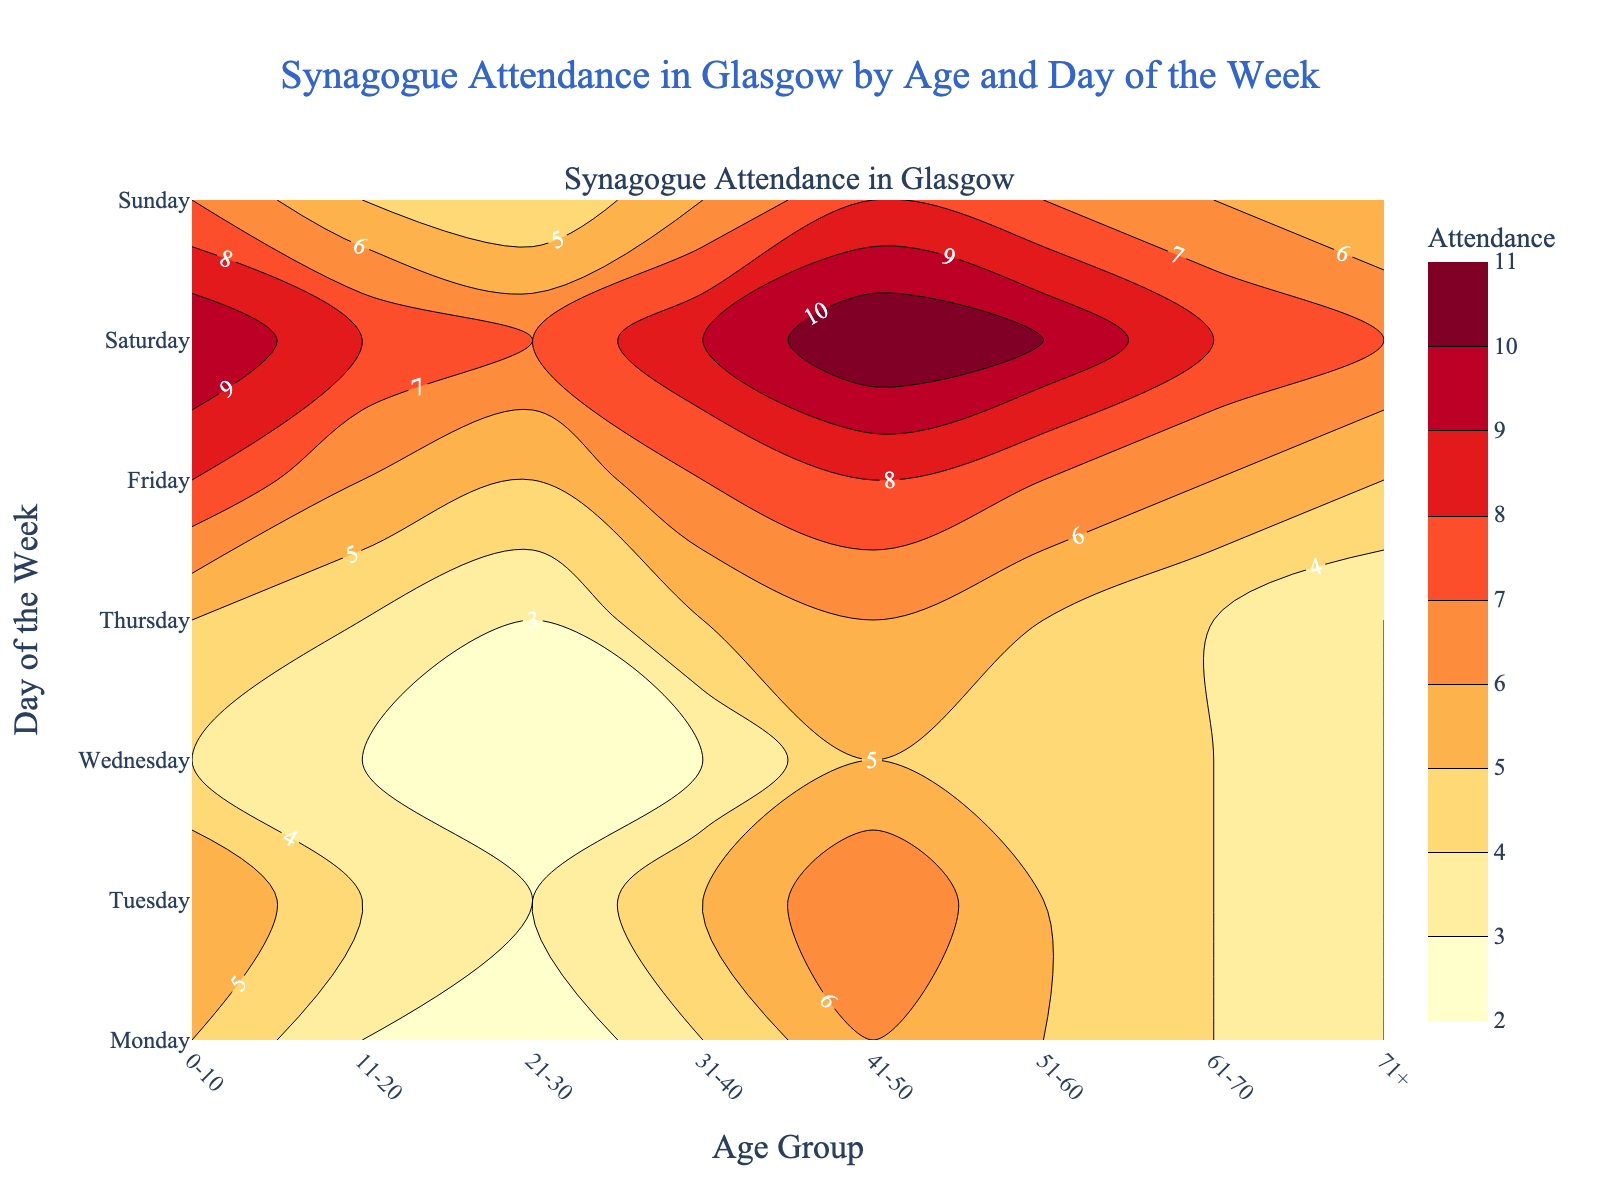What is the title of the figure? The title of the figure is usually positioned at the top center. In this case, it reads "Synagogue Attendance in Glasgow by Age and Day of the Week."
Answer: Synagogue Attendance in Glasgow by Age and Day of the Week What does the color bar represent? The color bar on the right side of the contour plot indicates the number of attendances. Different colors correspond to different attendance levels, with a scale from lower attendance (lighter color) to higher attendance (darker color).
Answer: Attendance Which day has the highest overall synagogue attendance? The highest attendance is indicated by the darkest color in the plot. Saturday features the most frequent darkest tones, reflecting the largest number of attendees across all age groups.
Answer: Saturday Which age group has the highest attendance on Friday? On Friday, the darkest color (indicative of the highest attendance) corresponds to the age group 0-10.
Answer: 0-10 What is the average attendance of the age group 31-40 across all days? To find the average, sum the attendance for the 31-40 age group over all days and then divide by the number of days: (4+5+3+5+7+9+6)/7 = 39/7 = 5.57 (approximately).
Answer: 5.57 On which days does the age group 61-70 have an attendance greater than 4? By examining positions corresponding to the 61-70 age group, we observe numbers and shading: Friday and Saturday are the days with an attendance of 6 and 8 respectively, both greater than 4.
Answer: Friday, Saturday How does the attendance on Sunday for the age group 41-50 compare to the attendance on Wednesday for the same age group? On Sunday, the 41-50 group has an attendance of 8, while on Wednesday, it is 5. Therefore, the attendance on Sunday is greater.
Answer: Sunday is greater What pattern do you observe in synagogue attendance over the week? From Monday to Thursday, attendance remains relatively steady, then increases significantly on Friday and peaks on Saturday, before slightly decreasing on Sunday. This presents a trend where attendance is highest leading into and on Sabbath (Saturday).
Answer: Peaks on Saturday Is there any age group whose attendance does not vary significantly throughout the week? The age group 71+ shows consistent attendance figures, staying at 3 to 5 throughout the week, implying low variation.
Answer: 71+ What is the total attendance for the age group 0-10? Sum up the attendance for the 0-10 age group over all days: 5 (Mon) + 6 (Tue) + 4 (Wed) + 5 (Thu) + 8 (Fri) + 10 (Sat) + 7 (Sun) = 45.
Answer: 45 